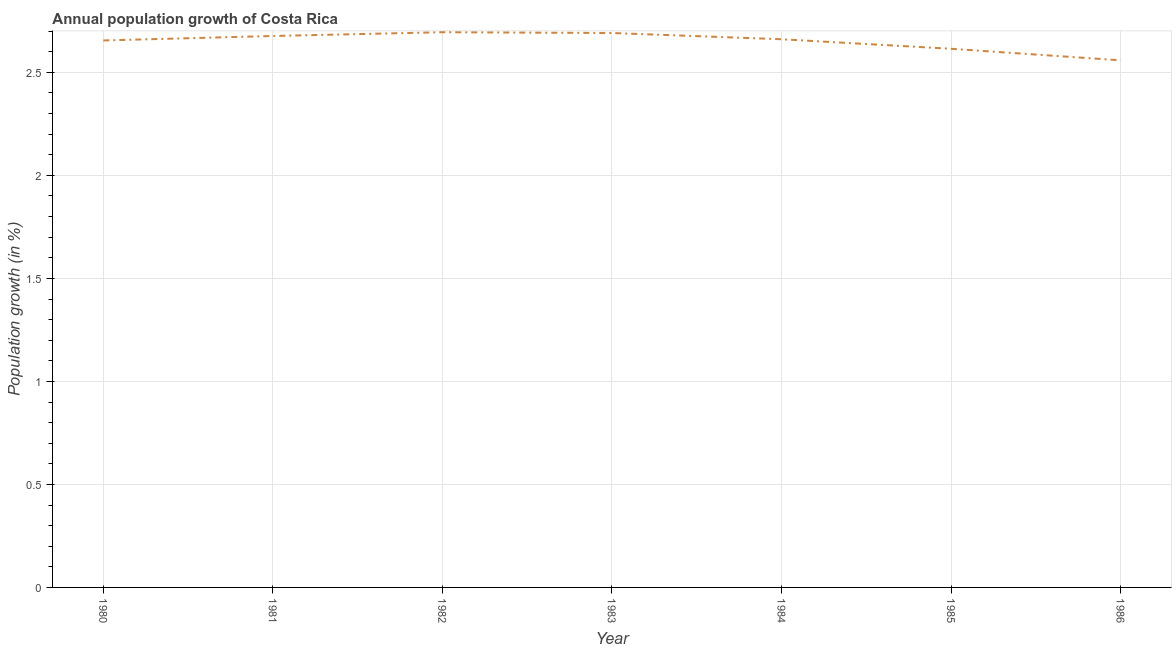What is the population growth in 1982?
Offer a terse response. 2.69. Across all years, what is the maximum population growth?
Keep it short and to the point. 2.69. Across all years, what is the minimum population growth?
Your response must be concise. 2.56. What is the sum of the population growth?
Make the answer very short. 18.55. What is the difference between the population growth in 1983 and 1985?
Ensure brevity in your answer.  0.08. What is the average population growth per year?
Provide a succinct answer. 2.65. What is the median population growth?
Ensure brevity in your answer.  2.66. Do a majority of the years between 1984 and 1983 (inclusive) have population growth greater than 0.8 %?
Give a very brief answer. No. What is the ratio of the population growth in 1984 to that in 1985?
Provide a succinct answer. 1.02. Is the difference between the population growth in 1980 and 1982 greater than the difference between any two years?
Your answer should be compact. No. What is the difference between the highest and the second highest population growth?
Offer a very short reply. 0. What is the difference between the highest and the lowest population growth?
Keep it short and to the point. 0.14. Does the population growth monotonically increase over the years?
Your answer should be compact. No. How many lines are there?
Offer a terse response. 1. How many years are there in the graph?
Provide a short and direct response. 7. What is the difference between two consecutive major ticks on the Y-axis?
Provide a succinct answer. 0.5. Does the graph contain grids?
Keep it short and to the point. Yes. What is the title of the graph?
Provide a succinct answer. Annual population growth of Costa Rica. What is the label or title of the Y-axis?
Offer a terse response. Population growth (in %). What is the Population growth (in %) in 1980?
Provide a short and direct response. 2.65. What is the Population growth (in %) in 1981?
Your response must be concise. 2.68. What is the Population growth (in %) in 1982?
Offer a terse response. 2.69. What is the Population growth (in %) of 1983?
Offer a very short reply. 2.69. What is the Population growth (in %) of 1984?
Make the answer very short. 2.66. What is the Population growth (in %) of 1985?
Provide a short and direct response. 2.61. What is the Population growth (in %) of 1986?
Give a very brief answer. 2.56. What is the difference between the Population growth (in %) in 1980 and 1981?
Give a very brief answer. -0.02. What is the difference between the Population growth (in %) in 1980 and 1982?
Provide a short and direct response. -0.04. What is the difference between the Population growth (in %) in 1980 and 1983?
Offer a terse response. -0.04. What is the difference between the Population growth (in %) in 1980 and 1984?
Give a very brief answer. -0.01. What is the difference between the Population growth (in %) in 1980 and 1985?
Make the answer very short. 0.04. What is the difference between the Population growth (in %) in 1980 and 1986?
Provide a succinct answer. 0.1. What is the difference between the Population growth (in %) in 1981 and 1982?
Your answer should be compact. -0.02. What is the difference between the Population growth (in %) in 1981 and 1983?
Offer a terse response. -0.01. What is the difference between the Population growth (in %) in 1981 and 1984?
Make the answer very short. 0.02. What is the difference between the Population growth (in %) in 1981 and 1985?
Make the answer very short. 0.06. What is the difference between the Population growth (in %) in 1981 and 1986?
Provide a succinct answer. 0.12. What is the difference between the Population growth (in %) in 1982 and 1983?
Provide a succinct answer. 0. What is the difference between the Population growth (in %) in 1982 and 1984?
Give a very brief answer. 0.03. What is the difference between the Population growth (in %) in 1982 and 1985?
Your answer should be compact. 0.08. What is the difference between the Population growth (in %) in 1982 and 1986?
Offer a very short reply. 0.14. What is the difference between the Population growth (in %) in 1983 and 1984?
Make the answer very short. 0.03. What is the difference between the Population growth (in %) in 1983 and 1985?
Your answer should be compact. 0.08. What is the difference between the Population growth (in %) in 1983 and 1986?
Offer a terse response. 0.13. What is the difference between the Population growth (in %) in 1984 and 1985?
Give a very brief answer. 0.05. What is the difference between the Population growth (in %) in 1984 and 1986?
Provide a short and direct response. 0.1. What is the difference between the Population growth (in %) in 1985 and 1986?
Keep it short and to the point. 0.06. What is the ratio of the Population growth (in %) in 1980 to that in 1982?
Your answer should be very brief. 0.98. What is the ratio of the Population growth (in %) in 1980 to that in 1985?
Offer a very short reply. 1.01. What is the ratio of the Population growth (in %) in 1980 to that in 1986?
Provide a succinct answer. 1.04. What is the ratio of the Population growth (in %) in 1981 to that in 1983?
Ensure brevity in your answer.  0.99. What is the ratio of the Population growth (in %) in 1981 to that in 1984?
Your answer should be compact. 1.01. What is the ratio of the Population growth (in %) in 1981 to that in 1986?
Your response must be concise. 1.05. What is the ratio of the Population growth (in %) in 1982 to that in 1983?
Your answer should be very brief. 1. What is the ratio of the Population growth (in %) in 1982 to that in 1984?
Your answer should be very brief. 1.01. What is the ratio of the Population growth (in %) in 1982 to that in 1985?
Provide a short and direct response. 1.03. What is the ratio of the Population growth (in %) in 1982 to that in 1986?
Offer a terse response. 1.05. What is the ratio of the Population growth (in %) in 1983 to that in 1984?
Your response must be concise. 1.01. What is the ratio of the Population growth (in %) in 1983 to that in 1986?
Make the answer very short. 1.05. 